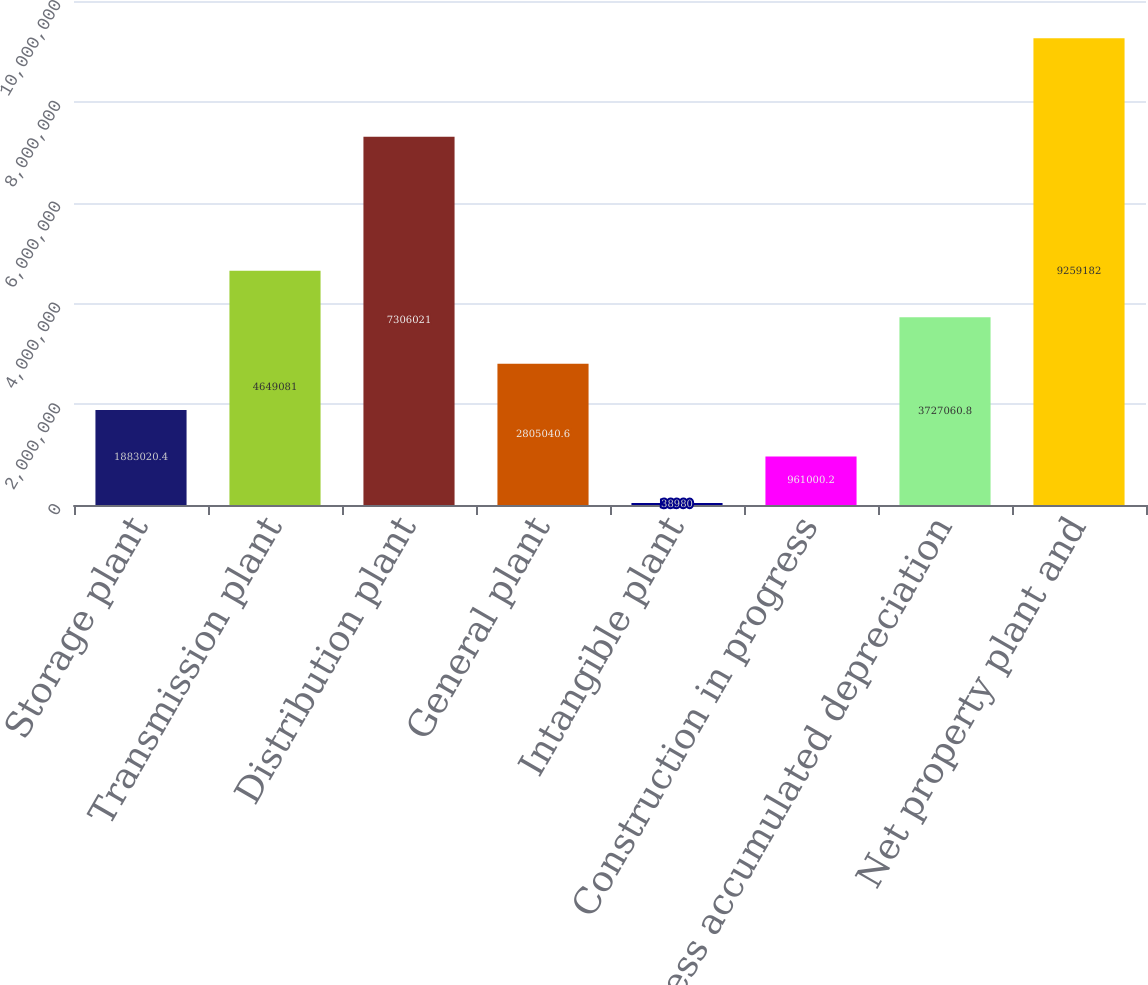Convert chart to OTSL. <chart><loc_0><loc_0><loc_500><loc_500><bar_chart><fcel>Storage plant<fcel>Transmission plant<fcel>Distribution plant<fcel>General plant<fcel>Intangible plant<fcel>Construction in progress<fcel>Less accumulated depreciation<fcel>Net property plant and<nl><fcel>1.88302e+06<fcel>4.64908e+06<fcel>7.30602e+06<fcel>2.80504e+06<fcel>38980<fcel>961000<fcel>3.72706e+06<fcel>9.25918e+06<nl></chart> 